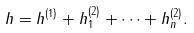Convert formula to latex. <formula><loc_0><loc_0><loc_500><loc_500>h = h ^ { ( 1 ) } + h ^ { ( 2 ) } _ { 1 } + \dots + h ^ { ( 2 ) } _ { n } .</formula> 